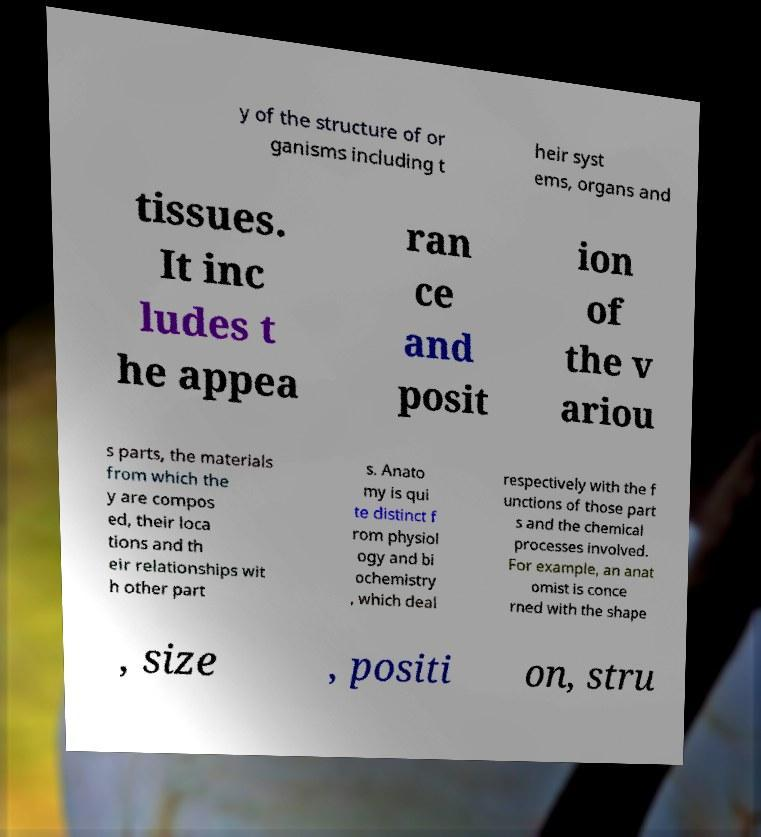Can you read and provide the text displayed in the image?This photo seems to have some interesting text. Can you extract and type it out for me? y of the structure of or ganisms including t heir syst ems, organs and tissues. It inc ludes t he appea ran ce and posit ion of the v ariou s parts, the materials from which the y are compos ed, their loca tions and th eir relationships wit h other part s. Anato my is qui te distinct f rom physiol ogy and bi ochemistry , which deal respectively with the f unctions of those part s and the chemical processes involved. For example, an anat omist is conce rned with the shape , size , positi on, stru 